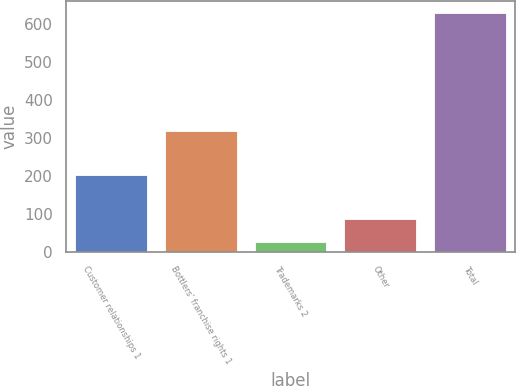<chart> <loc_0><loc_0><loc_500><loc_500><bar_chart><fcel>Customer relationships 1<fcel>Bottlers' franchise rights 1<fcel>Trademarks 2<fcel>Other<fcel>Total<nl><fcel>202<fcel>317<fcel>26<fcel>86.2<fcel>628<nl></chart> 